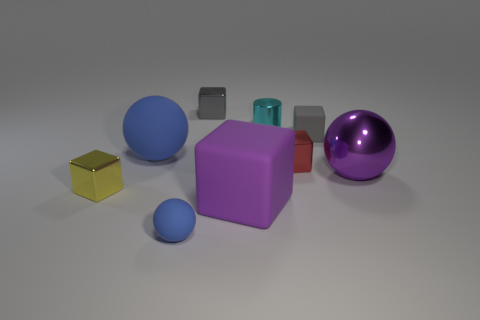The large blue thing that is made of the same material as the purple cube is what shape?
Offer a terse response. Sphere. Are any large red rubber cylinders visible?
Provide a short and direct response. No. Is the number of gray blocks on the right side of the large purple rubber cube less than the number of large blocks behind the tiny red metal block?
Your response must be concise. No. What is the shape of the thing that is in front of the purple rubber object?
Offer a terse response. Sphere. Does the purple sphere have the same material as the tiny yellow block?
Offer a very short reply. Yes. There is a purple thing that is the same shape as the tiny yellow metal object; what is its material?
Provide a succinct answer. Rubber. Is the number of purple metallic spheres that are to the right of the gray metal block less than the number of small blue balls?
Make the answer very short. No. How many gray objects are in front of the big blue sphere?
Your answer should be very brief. 0. There is a purple object on the right side of the cyan cylinder; is it the same shape as the small rubber object that is behind the small ball?
Ensure brevity in your answer.  No. There is a rubber thing that is both to the right of the gray metal object and behind the large purple block; what shape is it?
Your answer should be very brief. Cube. 